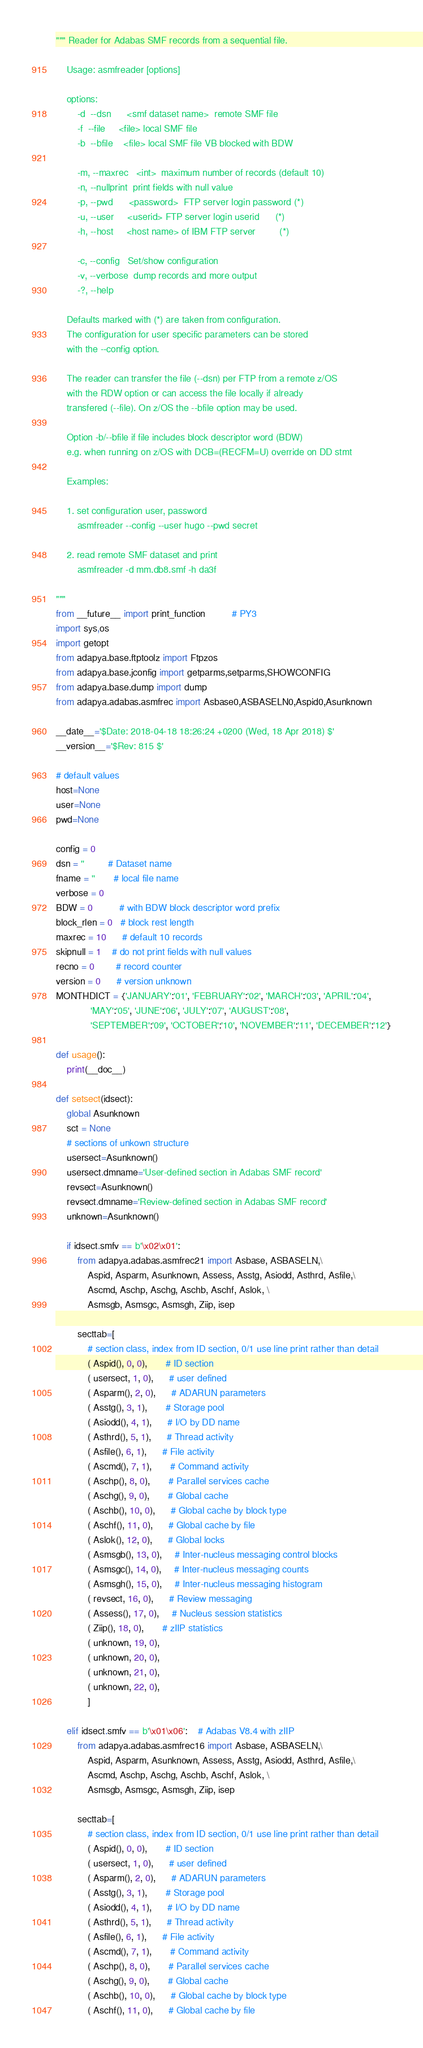Convert code to text. <code><loc_0><loc_0><loc_500><loc_500><_Python_>""" Reader for Adabas SMF records from a sequential file.

    Usage: asmfreader [options]

    options:
        -d  --dsn      <smf dataset name>  remote SMF file
        -f  --file     <file> local SMF file
        -b  --bfile    <file> local SMF file VB blocked with BDW

        -m, --maxrec   <int>  maximum number of records (default 10)
        -n, --nullprint  print fields with null value
        -p, --pwd      <password>  FTP server login password (*)
        -u, --user     <userid> FTP server login userid      (*)
        -h, --host     <host name> of IBM FTP server         (*)

        -c, --config   Set/show configuration
        -v, --verbose  dump records and more output
        -?, --help

    Defaults marked with (*) are taken from configuration.
    The configuration for user specific parameters can be stored
    with the --config option.

    The reader can transfer the file (--dsn) per FTP from a remote z/OS
    with the RDW option or can access the file locally if already
    transfered (--file). On z/OS the --bfile option may be used.

    Option -b/--bfile if file includes block descriptor word (BDW)
    e.g. when running on z/OS with DCB=(RECFM=U) override on DD stmt

    Examples:

    1. set configuration user, password
        asmfreader --config --user hugo --pwd secret

    2. read remote SMF dataset and print
        asmfreader -d mm.db8.smf -h da3f

"""
from __future__ import print_function          # PY3
import sys,os
import getopt
from adapya.base.ftptoolz import Ftpzos
from adapya.base.jconfig import getparms,setparms,SHOWCONFIG
from adapya.base.dump import dump
from adapya.adabas.asmfrec import Asbase0,ASBASELN0,Aspid0,Asunknown

__date__='$Date: 2018-04-18 18:26:24 +0200 (Wed, 18 Apr 2018) $'
__version__='$Rev: 815 $'

# default values
host=None
user=None
pwd=None

config = 0
dsn = ''         # Dataset name
fname = ''       # local file name
verbose = 0
BDW = 0          # with BDW block descriptor word prefix
block_rlen = 0   # block rest length
maxrec = 10      # default 10 records
skipnull = 1    # do not print fields with null values
recno = 0        # record counter
version = 0      # version unknown
MONTHDICT = {'JANUARY':'01', 'FEBRUARY':'02', 'MARCH':'03', 'APRIL':'04',
             'MAY':'05', 'JUNE':'06', 'JULY':'07', 'AUGUST':'08',
             'SEPTEMBER':'09', 'OCTOBER':'10', 'NOVEMBER':'11', 'DECEMBER':'12'}

def usage():
    print(__doc__)

def setsect(idsect):
    global Asunknown
    sct = None
    # sections of unkown structure
    usersect=Asunknown()
    usersect.dmname='User-defined section in Adabas SMF record'
    revsect=Asunknown()
    revsect.dmname='Review-defined section in Adabas SMF record'
    unknown=Asunknown()

    if idsect.smfv == b'\x02\x01':
        from adapya.adabas.asmfrec21 import Asbase, ASBASELN,\
            Aspid, Asparm, Asunknown, Assess, Asstg, Asiodd, Asthrd, Asfile,\
            Ascmd, Aschp, Aschg, Aschb, Aschf, Aslok, \
            Asmsgb, Asmsgc, Asmsgh, Ziip, isep

        secttab=[
            # section class, index from ID section, 0/1 use line print rather than detail
            ( Aspid(), 0, 0),       # ID section
            ( usersect, 1, 0),      # user defined
            ( Asparm(), 2, 0),      # ADARUN parameters
            ( Asstg(), 3, 1),       # Storage pool
            ( Asiodd(), 4, 1),      # I/O by DD name
            ( Asthrd(), 5, 1),      # Thread activity
            ( Asfile(), 6, 1),      # File activity
            ( Ascmd(), 7, 1),       # Command activity
            ( Aschp(), 8, 0),       # Parallel services cache
            ( Aschg(), 9, 0),       # Global cache
            ( Aschb(), 10, 0),      # Global cache by block type
            ( Aschf(), 11, 0),      # Global cache by file
            ( Aslok(), 12, 0),      # Global locks
            ( Asmsgb(), 13, 0),     # Inter-nucleus messaging control blocks
            ( Asmsgc(), 14, 0),     # Inter-nucleus messaging counts
            ( Asmsgh(), 15, 0),     # Inter-nucleus messaging histogram
            ( revsect, 16, 0),      # Review messaging
            ( Assess(), 17, 0),     # Nucleus session statistics
            ( Ziip(), 18, 0),       # zIIP statistics
            ( unknown, 19, 0),
            ( unknown, 20, 0),
            ( unknown, 21, 0),
            ( unknown, 22, 0),
            ]

    elif idsect.smfv == b'\x01\x06':    # Adabas V8.4 with zIIP
        from adapya.adabas.asmfrec16 import Asbase, ASBASELN,\
            Aspid, Asparm, Asunknown, Assess, Asstg, Asiodd, Asthrd, Asfile,\
            Ascmd, Aschp, Aschg, Aschb, Aschf, Aslok, \
            Asmsgb, Asmsgc, Asmsgh, Ziip, isep

        secttab=[
            # section class, index from ID section, 0/1 use line print rather than detail
            ( Aspid(), 0, 0),       # ID section
            ( usersect, 1, 0),      # user defined
            ( Asparm(), 2, 0),      # ADARUN parameters
            ( Asstg(), 3, 1),       # Storage pool
            ( Asiodd(), 4, 1),      # I/O by DD name
            ( Asthrd(), 5, 1),      # Thread activity
            ( Asfile(), 6, 1),      # File activity
            ( Ascmd(), 7, 1),       # Command activity
            ( Aschp(), 8, 0),       # Parallel services cache
            ( Aschg(), 9, 0),       # Global cache
            ( Aschb(), 10, 0),      # Global cache by block type
            ( Aschf(), 11, 0),      # Global cache by file</code> 